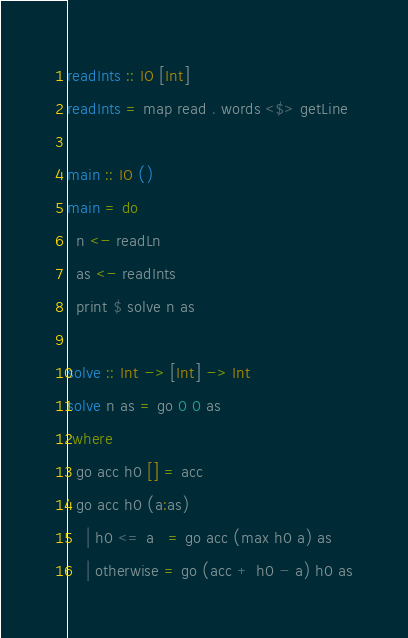Convert code to text. <code><loc_0><loc_0><loc_500><loc_500><_Haskell_>readInts :: IO [Int]
readInts = map read . words <$> getLine

main :: IO ()
main = do
  n <- readLn
  as <- readInts
  print $ solve n as

solve :: Int -> [Int] -> Int
solve n as = go 0 0 as
 where
  go acc h0 [] = acc
  go acc h0 (a:as)
    | h0 <= a   = go acc (max h0 a) as
    | otherwise = go (acc + h0 - a) h0 as
</code> 